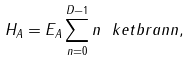<formula> <loc_0><loc_0><loc_500><loc_500>H _ { A } = E _ { A } \sum _ { n = 0 } ^ { D - 1 } n \ k e t b r a { n } { n } ,</formula> 